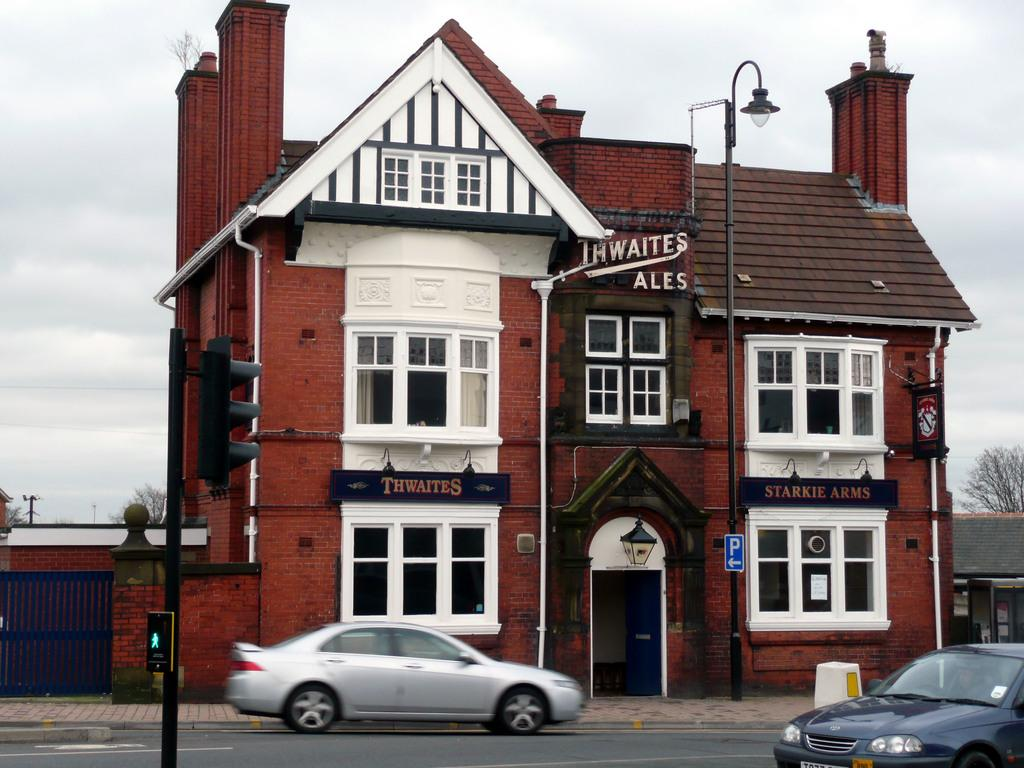What is the main subject of the image? The main subject of the image is a building. What is located in front of the building? There is a lamp and a signal in front of the building. What is happening on the road in front of the building? There are cars moving on the road in front of the building. What can be seen in the background of the image? There are trees and the sky visible in the background of the image. Where can the ants be found in the image? There are no ants present in the image. What historical event is depicted in the image? The image does not depict any historical event; it shows a building, a lamp, a signal, cars, trees, and the sky. 